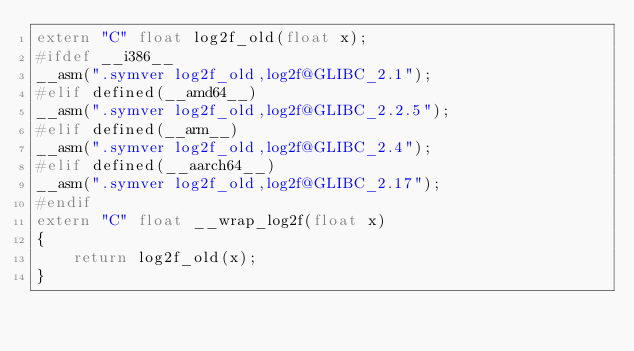Convert code to text. <code><loc_0><loc_0><loc_500><loc_500><_C++_>extern "C" float log2f_old(float x);
#ifdef __i386__
__asm(".symver log2f_old,log2f@GLIBC_2.1");
#elif defined(__amd64__)
__asm(".symver log2f_old,log2f@GLIBC_2.2.5");
#elif defined(__arm__)
__asm(".symver log2f_old,log2f@GLIBC_2.4");
#elif defined(__aarch64__)
__asm(".symver log2f_old,log2f@GLIBC_2.17");
#endif
extern "C" float __wrap_log2f(float x)
{
    return log2f_old(x);
}
</code> 